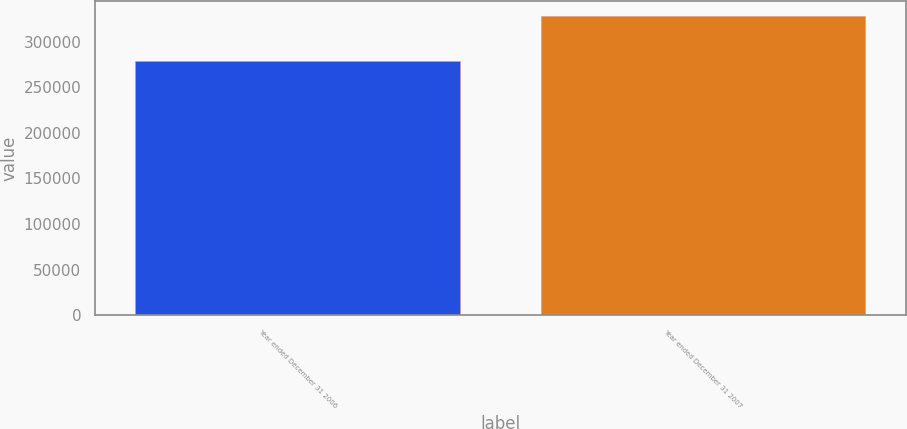Convert chart to OTSL. <chart><loc_0><loc_0><loc_500><loc_500><bar_chart><fcel>Year ended December 31 2006<fcel>Year ended December 31 2007<nl><fcel>278860<fcel>327738<nl></chart> 